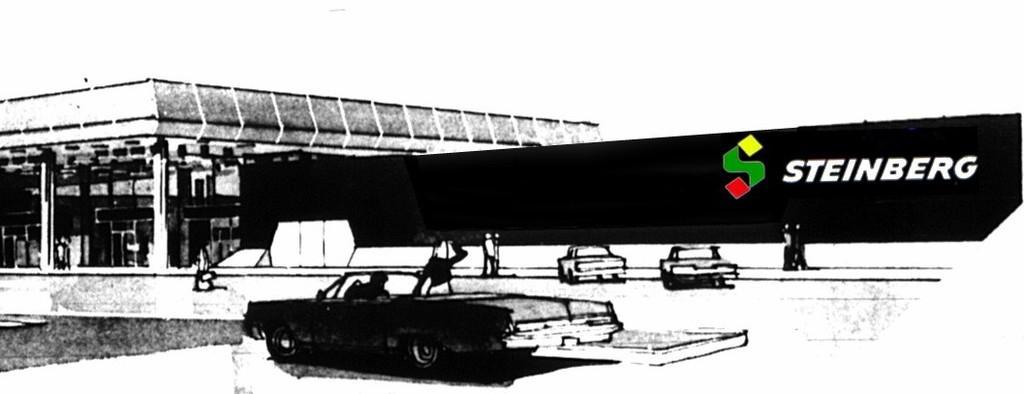Can you describe this image briefly? This picture is in black and white. In this picture, there is a sketch. At the bottom, there is a car, before it there are people. Towards the right, there is some text and a symbol with colors. Towards the left, there is a building. 